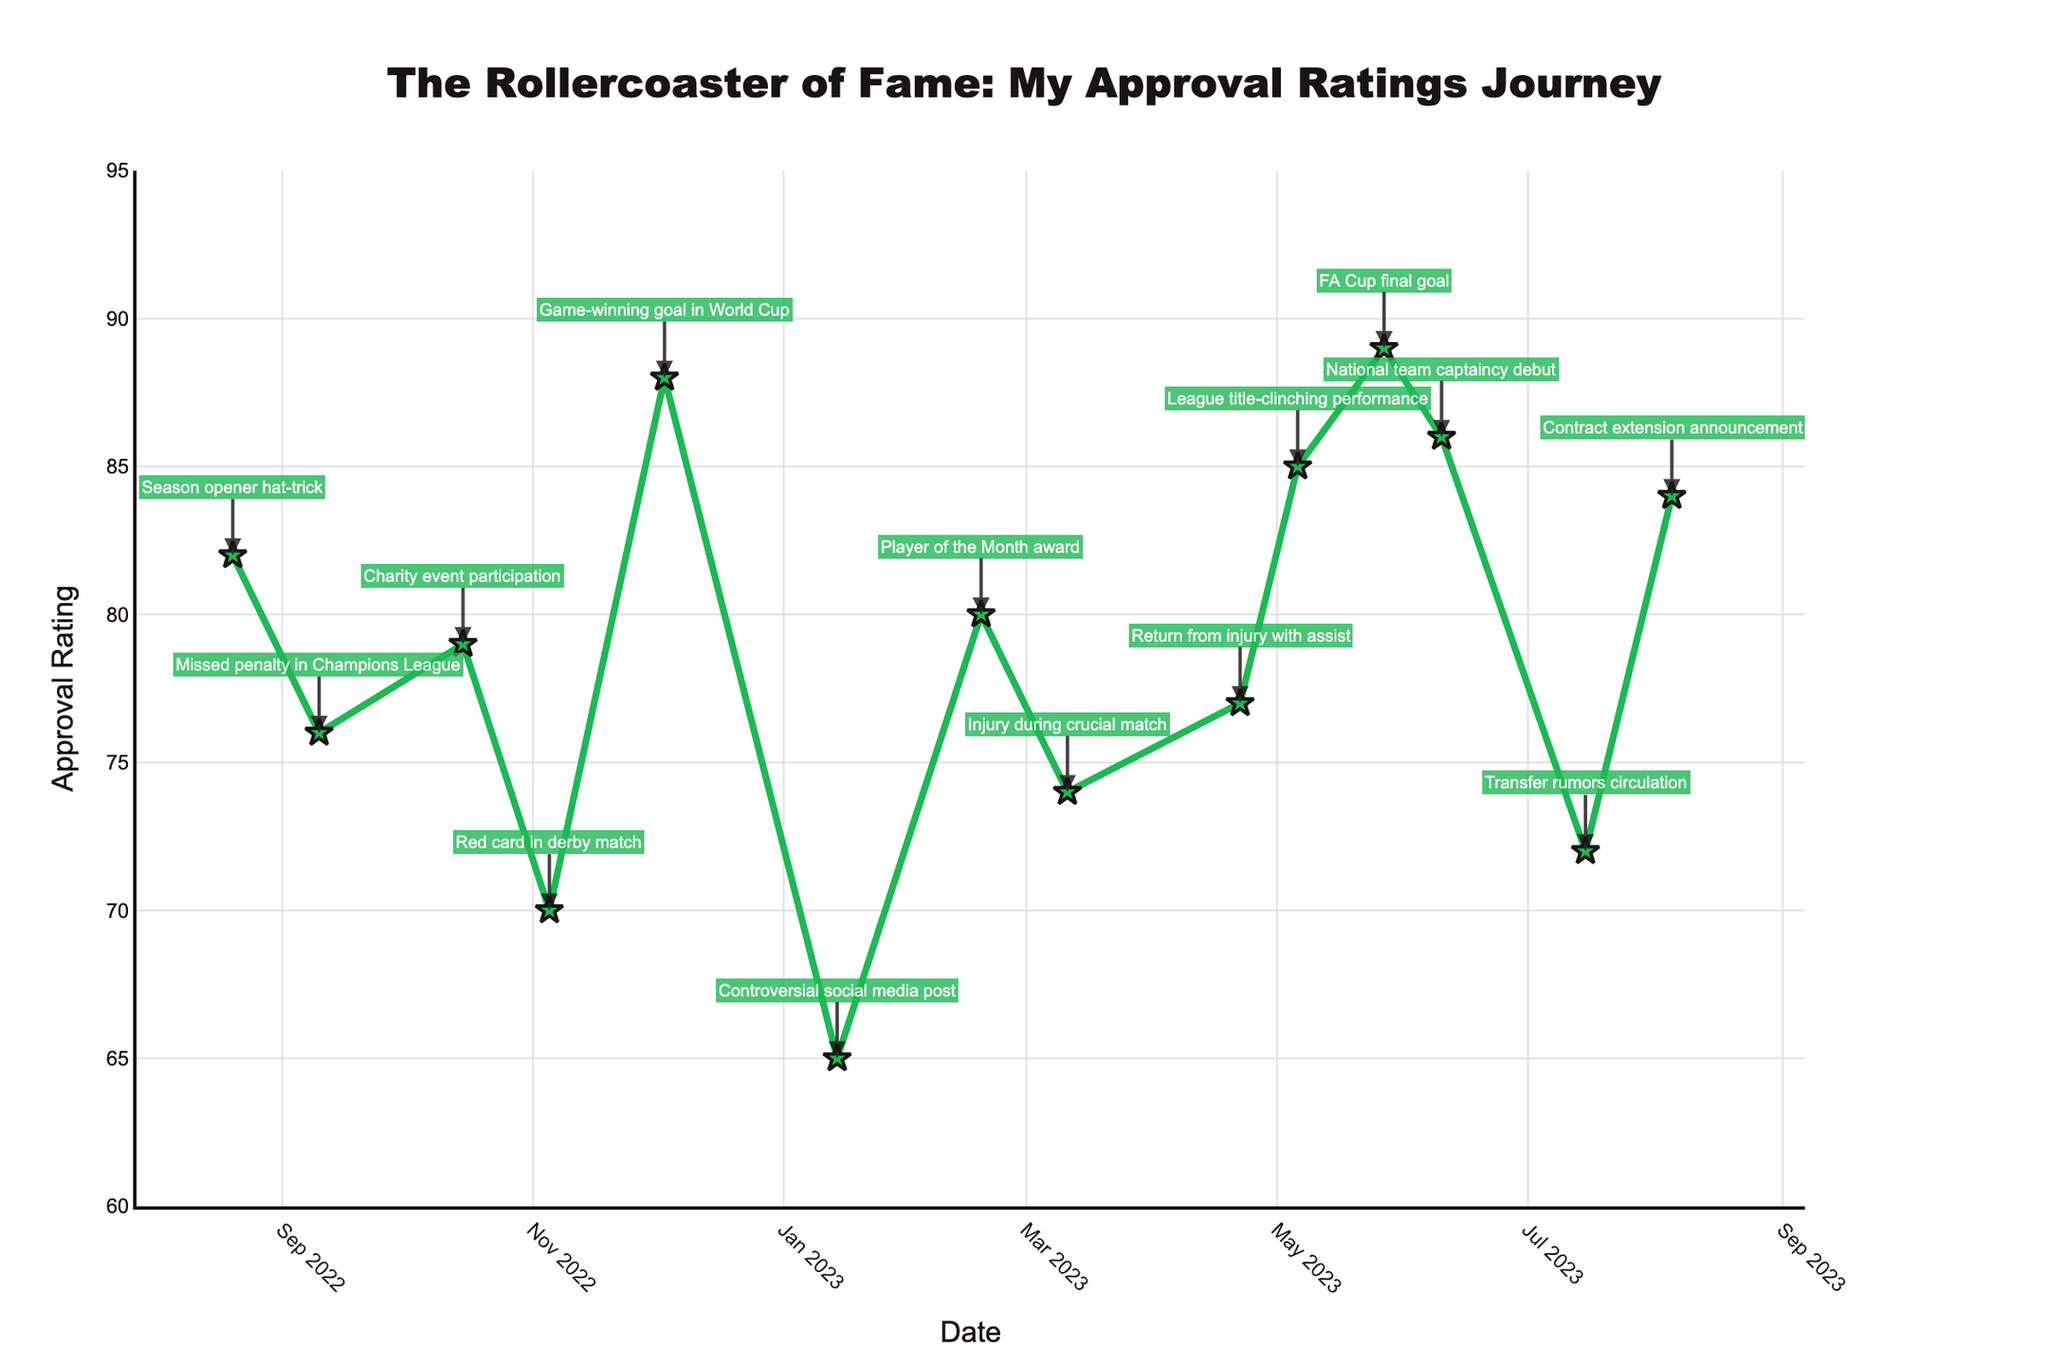What was the trend in approval rating following the missed penalty in the Champions League on September 10, 2022? The approval rating decreased from 82 to 76 after the missed penalty, showing a downward trend due to this event.
Answer: Decreased By how many points did the approval rating increase after the Game-winning goal in World Cup compared to the Red card in derby match? The approval rating increased from 70 (Red card in derby match) to 88 (Game-winning goal in World Cup), resulting in a difference of 18 points.
Answer: 18 points Which event marked the highest peak in approval ratings during this period? The highest approval rating (89) was achieved after scoring the goal in the FA Cup final on May 27, 2023.
Answer: FA Cup final goal How did the approval rating change after the controversial social media post? The approval rating dropped significantly from 88 (after the World Cup goal) to 65 following the controversial social media post.
Answer: Dropped significantly Was the approval rating higher after participation in the charity event or after the Player of the Month award? After the Player of the Month award, the rating was 80, which is higher compared to the 79 after the charity event.
Answer: Player of the Month award What were the approval ratings before and after your injury during a crucial match, and what was the difference? Before the injury on March 11, 2023, the rating was 80, and it decreased to 74 after the injury, resulting in a difference of 6 points.
Answer: 6 points What was the net change in approval rating from the start to the end of the period? At the beginning (August 20, 2022), the approval rating was 82, and at the end (August 5, 2023), it was 84, resulting in a net increase of 2 points.
Answer: 2 points Which event caused the greatest drop in approval ratings, and by how many points did it fall? The controversial social media post on January 14, 2023, caused the greatest drop, with approval rating falling from 88 to 65, a decrease of 23 points.
Answer: Controversial social media post, 23 points 